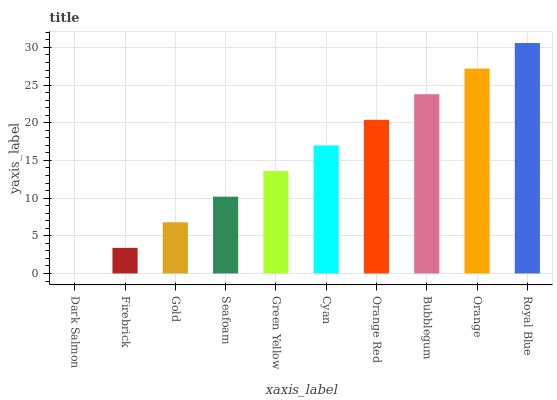Is Dark Salmon the minimum?
Answer yes or no. Yes. Is Royal Blue the maximum?
Answer yes or no. Yes. Is Firebrick the minimum?
Answer yes or no. No. Is Firebrick the maximum?
Answer yes or no. No. Is Firebrick greater than Dark Salmon?
Answer yes or no. Yes. Is Dark Salmon less than Firebrick?
Answer yes or no. Yes. Is Dark Salmon greater than Firebrick?
Answer yes or no. No. Is Firebrick less than Dark Salmon?
Answer yes or no. No. Is Cyan the high median?
Answer yes or no. Yes. Is Green Yellow the low median?
Answer yes or no. Yes. Is Seafoam the high median?
Answer yes or no. No. Is Firebrick the low median?
Answer yes or no. No. 